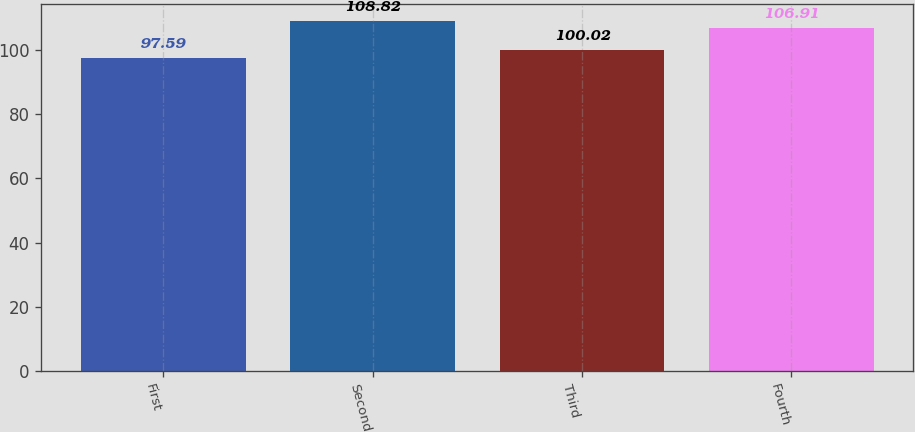Convert chart. <chart><loc_0><loc_0><loc_500><loc_500><bar_chart><fcel>First<fcel>Second<fcel>Third<fcel>Fourth<nl><fcel>97.59<fcel>108.82<fcel>100.02<fcel>106.91<nl></chart> 